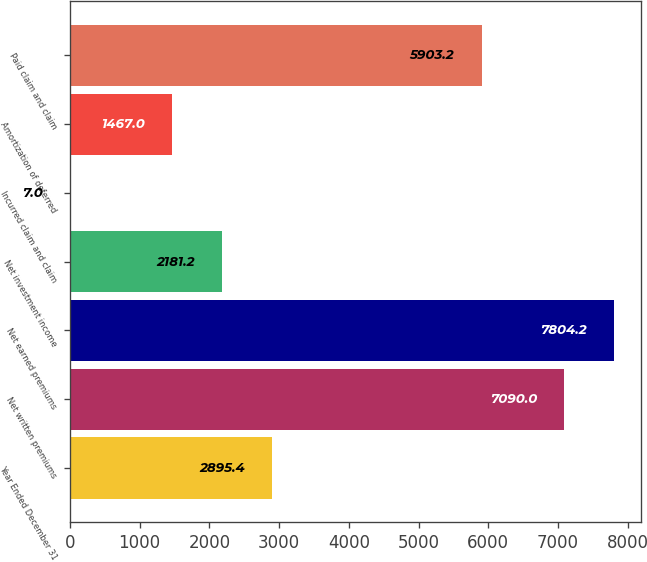Convert chart. <chart><loc_0><loc_0><loc_500><loc_500><bar_chart><fcel>Year Ended December 31<fcel>Net written premiums<fcel>Net earned premiums<fcel>Net investment income<fcel>Incurred claim and claim<fcel>Amortization of deferred<fcel>Paid claim and claim<nl><fcel>2895.4<fcel>7090<fcel>7804.2<fcel>2181.2<fcel>7<fcel>1467<fcel>5903.2<nl></chart> 